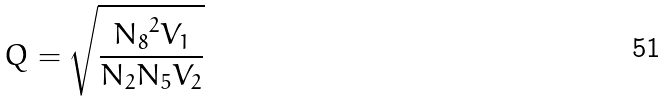Convert formula to latex. <formula><loc_0><loc_0><loc_500><loc_500>Q = \sqrt { \frac { { N _ { 8 } } ^ { 2 } V _ { 1 } } { N _ { 2 } N _ { 5 } V _ { 2 } } }</formula> 